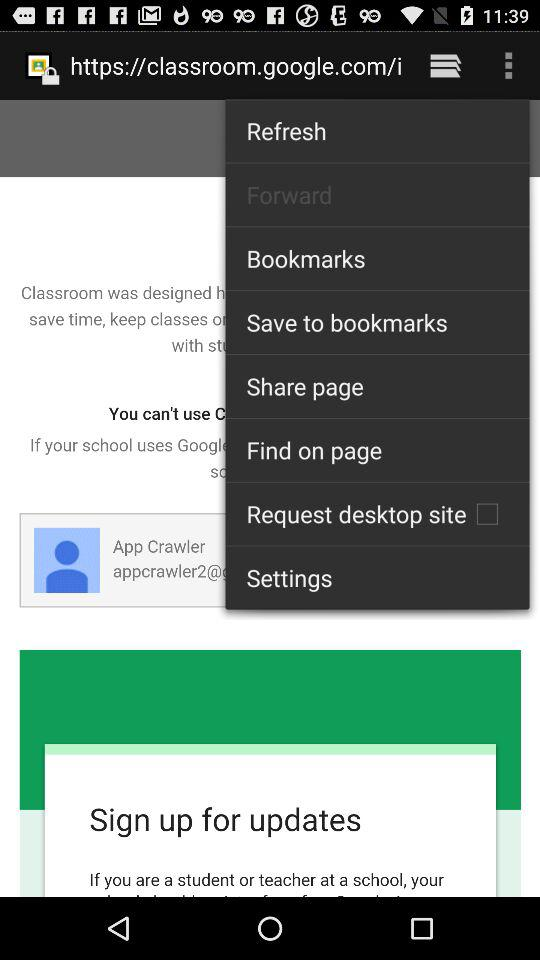What is the user name? The user name is App Crawler. 